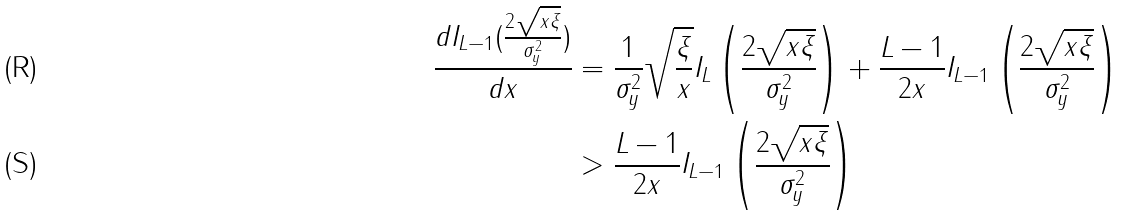Convert formula to latex. <formula><loc_0><loc_0><loc_500><loc_500>\frac { d I _ { L - 1 } ( \frac { 2 \sqrt { x \xi } } { \sigma _ { y } ^ { 2 } } ) } { d x } & = \frac { 1 } { \sigma _ { y } ^ { 2 } } \sqrt { \frac { \xi } { x } } I _ { L } \left ( \frac { 2 \sqrt { x \xi } } { \sigma _ { y } ^ { 2 } } \right ) + \frac { L - 1 } { 2 x } I _ { L - 1 } \left ( \frac { 2 \sqrt { x \xi } } { \sigma _ { y } ^ { 2 } } \right ) \\ & > \frac { L - 1 } { 2 x } I _ { L - 1 } \left ( \frac { 2 \sqrt { x \xi } } { \sigma _ { y } ^ { 2 } } \right )</formula> 